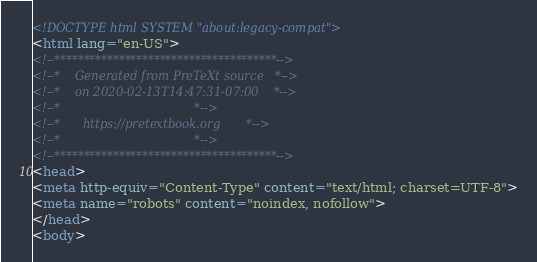Convert code to text. <code><loc_0><loc_0><loc_500><loc_500><_HTML_><!DOCTYPE html SYSTEM "about:legacy-compat">
<html lang="en-US">
<!--**************************************-->
<!--*    Generated from PreTeXt source   *-->
<!--*    on 2020-02-13T14:47:31-07:00    *-->
<!--*                                    *-->
<!--*      https://pretextbook.org       *-->
<!--*                                    *-->
<!--**************************************-->
<head>
<meta http-equiv="Content-Type" content="text/html; charset=UTF-8">
<meta name="robots" content="noindex, nofollow">
</head>
<body></code> 